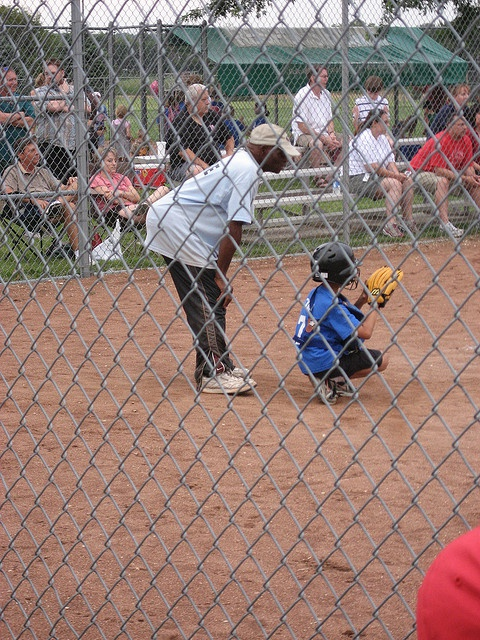Describe the objects in this image and their specific colors. I can see people in lightgray, darkgray, black, and gray tones, people in lightgray, black, gray, blue, and darkgray tones, people in lightgray, salmon, brown, and gray tones, people in lightgray, gray, darkgray, and black tones, and people in lightgray, gray, darkgray, and lavender tones in this image. 